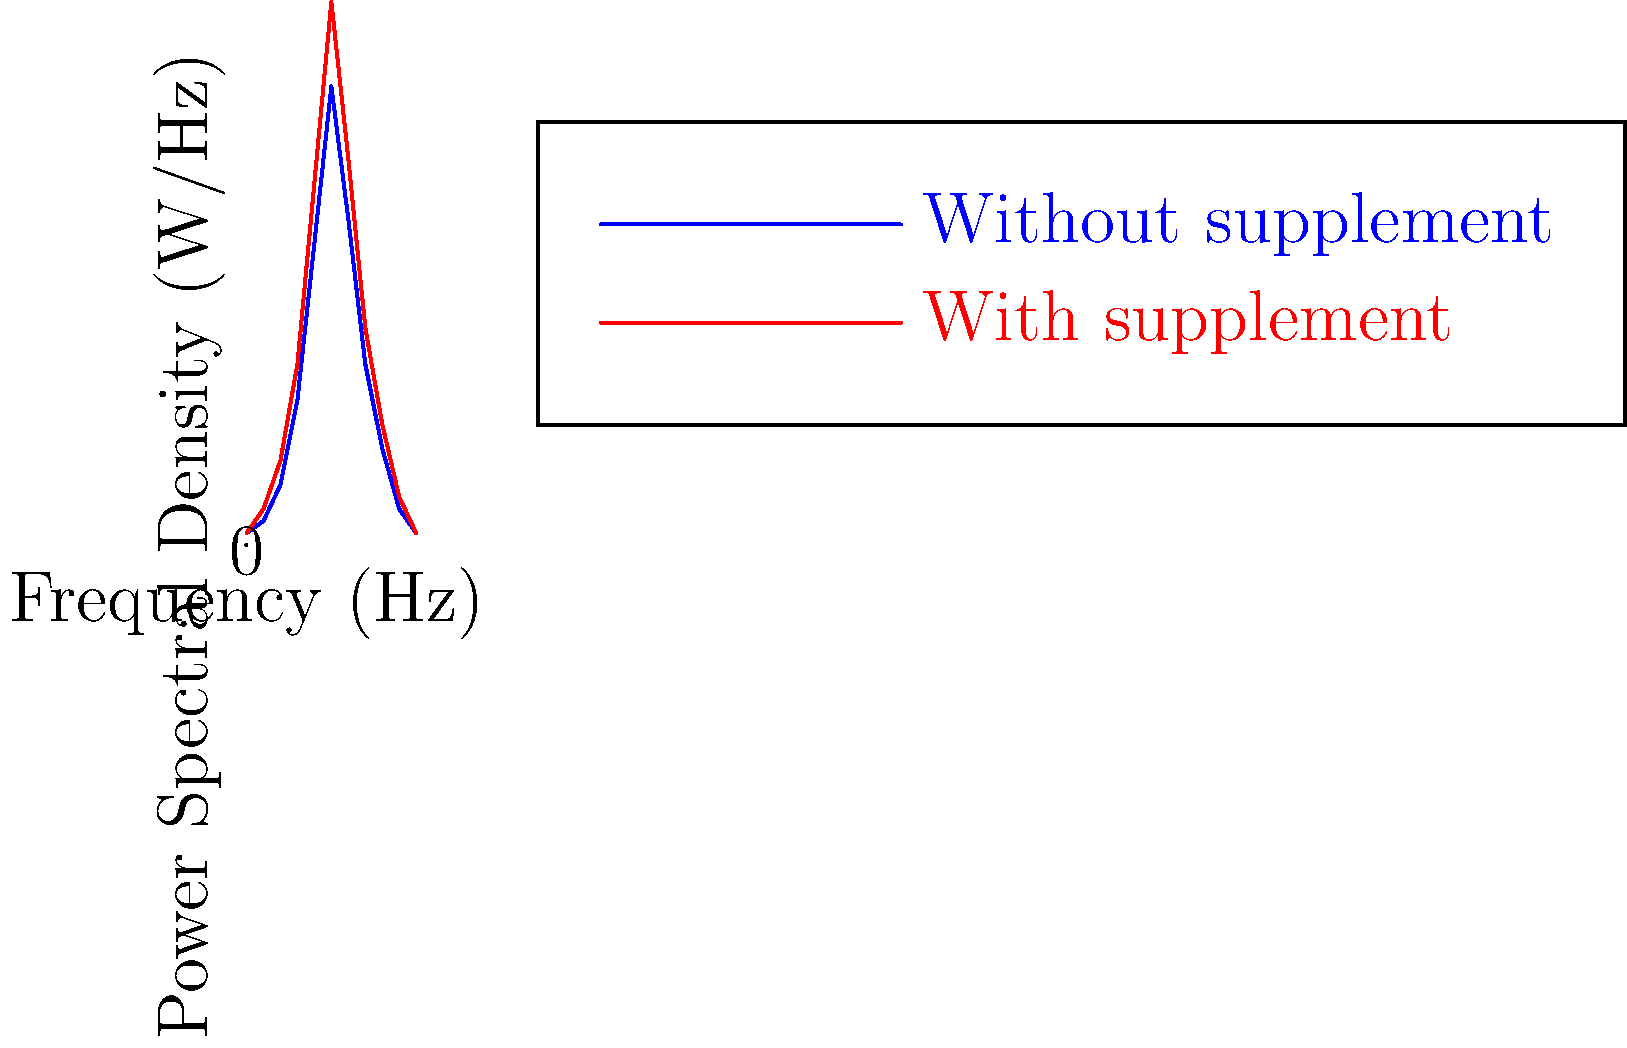As a researcher studying the effectiveness of supplements in enhancing endurance, you're analyzing power spectral density (PSD) plots of athletes' muscle activity during a standardized exercise test. The blue line represents the PSD without a supplement, while the red line shows the PSD with a supplement. Based on the graph, what can you conclude about the supplement's effect on muscle activity, and how might this relate to endurance performance? To interpret this power spectral density (PSD) plot and its implications for endurance performance, let's break down the analysis step-by-step:

1. PSD Comparison:
   The red line (with supplement) shows consistently higher PSD values across all frequencies compared to the blue line (without supplement).

2. Peak Analysis:
   Both curves peak around 5 Hz, but the supplement condition shows a higher peak magnitude.

3. Frequency Range:
   The supplement appears to increase power across the entire frequency spectrum (0-10 Hz).

4. Low-Frequency Components (0-3 Hz):
   These often represent slower, more sustained contractions. The supplement shows a slight increase in this range.

5. Mid-Frequency Components (3-7 Hz):
   This range typically corresponds to the main power output of muscle activity. The supplement shows a substantial increase here, particularly at the peak (5 Hz).

6. High-Frequency Components (7-10 Hz):
   These can represent faster, more precise movements or fatigue-related tremors. The supplement maintains a higher power in this range as well.

7. Implications for Muscle Activity:
   The overall increase in PSD suggests that the supplement is associated with greater muscle activation across various contraction speeds.

8. Endurance Performance:
   The increased power in the low and mid-frequency ranges could indicate enhanced sustained force production, which is crucial for endurance activities.

9. Potential Mechanisms:
   The supplement might be improving factors such as muscle fiber recruitment, motor unit synchronization, or energy availability to the muscles.

10. Considerations:
    While increased muscle activity can be beneficial, it's important to consider whether this translates to improved efficiency or if it might lead to earlier fatigue.
Answer: The supplement increases muscle activity across all frequencies, potentially enhancing force production and endurance performance. 